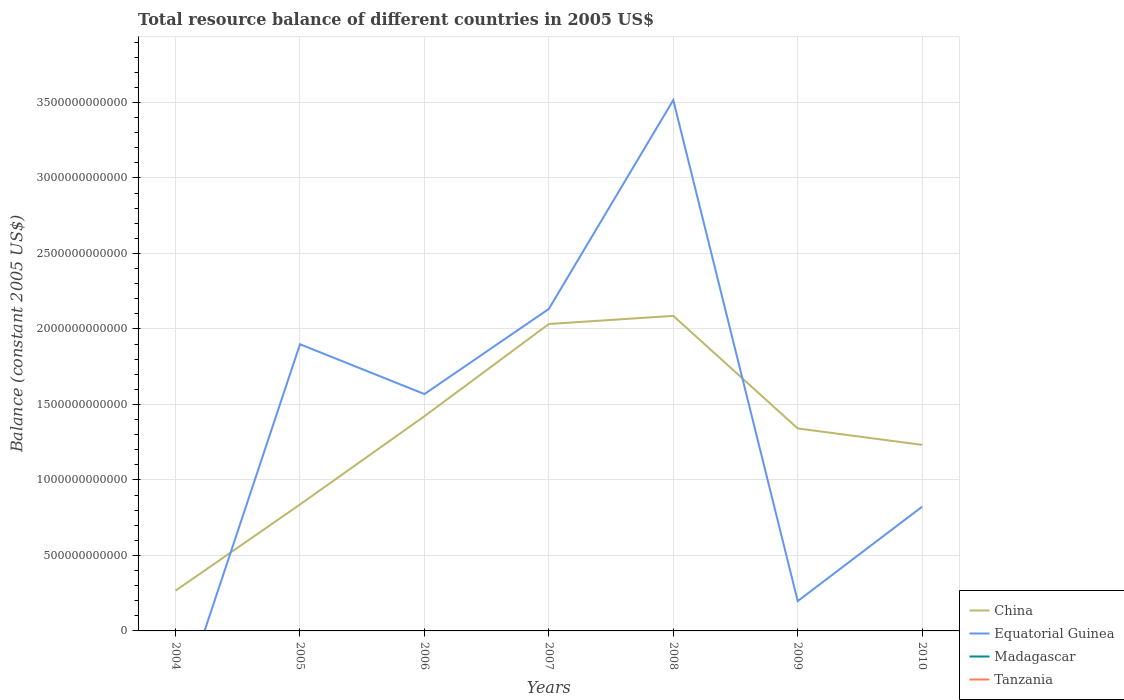How many different coloured lines are there?
Keep it short and to the point. 2. What is the total total resource balance in China in the graph?
Offer a very short reply. 1.09e+11. What is the difference between the highest and the second highest total resource balance in China?
Your response must be concise. 1.82e+12. Is the total resource balance in Equatorial Guinea strictly greater than the total resource balance in Madagascar over the years?
Provide a short and direct response. No. How many lines are there?
Ensure brevity in your answer.  2. What is the difference between two consecutive major ticks on the Y-axis?
Ensure brevity in your answer.  5.00e+11. Does the graph contain grids?
Your response must be concise. Yes. What is the title of the graph?
Your answer should be compact. Total resource balance of different countries in 2005 US$. Does "Cote d'Ivoire" appear as one of the legend labels in the graph?
Keep it short and to the point. No. What is the label or title of the X-axis?
Offer a terse response. Years. What is the label or title of the Y-axis?
Provide a short and direct response. Balance (constant 2005 US$). What is the Balance (constant 2005 US$) of China in 2004?
Ensure brevity in your answer.  2.67e+11. What is the Balance (constant 2005 US$) in China in 2005?
Offer a very short reply. 8.37e+11. What is the Balance (constant 2005 US$) of Equatorial Guinea in 2005?
Offer a very short reply. 1.90e+12. What is the Balance (constant 2005 US$) of Madagascar in 2005?
Your response must be concise. 0. What is the Balance (constant 2005 US$) in Tanzania in 2005?
Your answer should be very brief. 0. What is the Balance (constant 2005 US$) in China in 2006?
Make the answer very short. 1.42e+12. What is the Balance (constant 2005 US$) in Equatorial Guinea in 2006?
Make the answer very short. 1.57e+12. What is the Balance (constant 2005 US$) of Madagascar in 2006?
Provide a short and direct response. 0. What is the Balance (constant 2005 US$) of Tanzania in 2006?
Provide a succinct answer. 0. What is the Balance (constant 2005 US$) of China in 2007?
Provide a succinct answer. 2.03e+12. What is the Balance (constant 2005 US$) of Equatorial Guinea in 2007?
Your response must be concise. 2.13e+12. What is the Balance (constant 2005 US$) in China in 2008?
Offer a terse response. 2.09e+12. What is the Balance (constant 2005 US$) in Equatorial Guinea in 2008?
Offer a terse response. 3.52e+12. What is the Balance (constant 2005 US$) in Madagascar in 2008?
Ensure brevity in your answer.  0. What is the Balance (constant 2005 US$) in China in 2009?
Ensure brevity in your answer.  1.34e+12. What is the Balance (constant 2005 US$) in Equatorial Guinea in 2009?
Provide a succinct answer. 1.98e+11. What is the Balance (constant 2005 US$) in Tanzania in 2009?
Your answer should be compact. 0. What is the Balance (constant 2005 US$) of China in 2010?
Offer a very short reply. 1.23e+12. What is the Balance (constant 2005 US$) of Equatorial Guinea in 2010?
Give a very brief answer. 8.23e+11. Across all years, what is the maximum Balance (constant 2005 US$) of China?
Provide a succinct answer. 2.09e+12. Across all years, what is the maximum Balance (constant 2005 US$) in Equatorial Guinea?
Your response must be concise. 3.52e+12. Across all years, what is the minimum Balance (constant 2005 US$) of China?
Make the answer very short. 2.67e+11. Across all years, what is the minimum Balance (constant 2005 US$) of Equatorial Guinea?
Offer a very short reply. 0. What is the total Balance (constant 2005 US$) in China in the graph?
Your response must be concise. 9.22e+12. What is the total Balance (constant 2005 US$) of Equatorial Guinea in the graph?
Provide a short and direct response. 1.01e+13. What is the total Balance (constant 2005 US$) of Madagascar in the graph?
Your answer should be compact. 0. What is the difference between the Balance (constant 2005 US$) in China in 2004 and that in 2005?
Ensure brevity in your answer.  -5.71e+11. What is the difference between the Balance (constant 2005 US$) of China in 2004 and that in 2006?
Provide a short and direct response. -1.16e+12. What is the difference between the Balance (constant 2005 US$) in China in 2004 and that in 2007?
Offer a terse response. -1.77e+12. What is the difference between the Balance (constant 2005 US$) in China in 2004 and that in 2008?
Keep it short and to the point. -1.82e+12. What is the difference between the Balance (constant 2005 US$) of China in 2004 and that in 2009?
Offer a very short reply. -1.07e+12. What is the difference between the Balance (constant 2005 US$) in China in 2004 and that in 2010?
Offer a terse response. -9.66e+11. What is the difference between the Balance (constant 2005 US$) of China in 2005 and that in 2006?
Make the answer very short. -5.85e+11. What is the difference between the Balance (constant 2005 US$) of Equatorial Guinea in 2005 and that in 2006?
Offer a terse response. 3.30e+11. What is the difference between the Balance (constant 2005 US$) in China in 2005 and that in 2007?
Make the answer very short. -1.20e+12. What is the difference between the Balance (constant 2005 US$) in Equatorial Guinea in 2005 and that in 2007?
Your response must be concise. -2.34e+11. What is the difference between the Balance (constant 2005 US$) of China in 2005 and that in 2008?
Give a very brief answer. -1.25e+12. What is the difference between the Balance (constant 2005 US$) of Equatorial Guinea in 2005 and that in 2008?
Provide a short and direct response. -1.62e+12. What is the difference between the Balance (constant 2005 US$) in China in 2005 and that in 2009?
Offer a terse response. -5.04e+11. What is the difference between the Balance (constant 2005 US$) of Equatorial Guinea in 2005 and that in 2009?
Your answer should be compact. 1.70e+12. What is the difference between the Balance (constant 2005 US$) in China in 2005 and that in 2010?
Give a very brief answer. -3.95e+11. What is the difference between the Balance (constant 2005 US$) in Equatorial Guinea in 2005 and that in 2010?
Offer a terse response. 1.08e+12. What is the difference between the Balance (constant 2005 US$) in China in 2006 and that in 2007?
Give a very brief answer. -6.11e+11. What is the difference between the Balance (constant 2005 US$) in Equatorial Guinea in 2006 and that in 2007?
Keep it short and to the point. -5.64e+11. What is the difference between the Balance (constant 2005 US$) in China in 2006 and that in 2008?
Give a very brief answer. -6.65e+11. What is the difference between the Balance (constant 2005 US$) in Equatorial Guinea in 2006 and that in 2008?
Your answer should be compact. -1.95e+12. What is the difference between the Balance (constant 2005 US$) in China in 2006 and that in 2009?
Offer a terse response. 8.10e+1. What is the difference between the Balance (constant 2005 US$) in Equatorial Guinea in 2006 and that in 2009?
Provide a short and direct response. 1.37e+12. What is the difference between the Balance (constant 2005 US$) in China in 2006 and that in 2010?
Make the answer very short. 1.90e+11. What is the difference between the Balance (constant 2005 US$) in Equatorial Guinea in 2006 and that in 2010?
Provide a short and direct response. 7.46e+11. What is the difference between the Balance (constant 2005 US$) in China in 2007 and that in 2008?
Your response must be concise. -5.38e+1. What is the difference between the Balance (constant 2005 US$) in Equatorial Guinea in 2007 and that in 2008?
Offer a terse response. -1.38e+12. What is the difference between the Balance (constant 2005 US$) in China in 2007 and that in 2009?
Ensure brevity in your answer.  6.92e+11. What is the difference between the Balance (constant 2005 US$) of Equatorial Guinea in 2007 and that in 2009?
Your answer should be compact. 1.94e+12. What is the difference between the Balance (constant 2005 US$) in China in 2007 and that in 2010?
Make the answer very short. 8.01e+11. What is the difference between the Balance (constant 2005 US$) of Equatorial Guinea in 2007 and that in 2010?
Keep it short and to the point. 1.31e+12. What is the difference between the Balance (constant 2005 US$) of China in 2008 and that in 2009?
Ensure brevity in your answer.  7.46e+11. What is the difference between the Balance (constant 2005 US$) of Equatorial Guinea in 2008 and that in 2009?
Make the answer very short. 3.32e+12. What is the difference between the Balance (constant 2005 US$) of China in 2008 and that in 2010?
Keep it short and to the point. 8.54e+11. What is the difference between the Balance (constant 2005 US$) of Equatorial Guinea in 2008 and that in 2010?
Give a very brief answer. 2.69e+12. What is the difference between the Balance (constant 2005 US$) of China in 2009 and that in 2010?
Give a very brief answer. 1.09e+11. What is the difference between the Balance (constant 2005 US$) in Equatorial Guinea in 2009 and that in 2010?
Provide a succinct answer. -6.25e+11. What is the difference between the Balance (constant 2005 US$) in China in 2004 and the Balance (constant 2005 US$) in Equatorial Guinea in 2005?
Provide a short and direct response. -1.63e+12. What is the difference between the Balance (constant 2005 US$) of China in 2004 and the Balance (constant 2005 US$) of Equatorial Guinea in 2006?
Provide a short and direct response. -1.30e+12. What is the difference between the Balance (constant 2005 US$) of China in 2004 and the Balance (constant 2005 US$) of Equatorial Guinea in 2007?
Your answer should be very brief. -1.87e+12. What is the difference between the Balance (constant 2005 US$) in China in 2004 and the Balance (constant 2005 US$) in Equatorial Guinea in 2008?
Make the answer very short. -3.25e+12. What is the difference between the Balance (constant 2005 US$) of China in 2004 and the Balance (constant 2005 US$) of Equatorial Guinea in 2009?
Your response must be concise. 6.91e+1. What is the difference between the Balance (constant 2005 US$) of China in 2004 and the Balance (constant 2005 US$) of Equatorial Guinea in 2010?
Your answer should be compact. -5.56e+11. What is the difference between the Balance (constant 2005 US$) in China in 2005 and the Balance (constant 2005 US$) in Equatorial Guinea in 2006?
Offer a terse response. -7.31e+11. What is the difference between the Balance (constant 2005 US$) of China in 2005 and the Balance (constant 2005 US$) of Equatorial Guinea in 2007?
Your response must be concise. -1.30e+12. What is the difference between the Balance (constant 2005 US$) in China in 2005 and the Balance (constant 2005 US$) in Equatorial Guinea in 2008?
Your response must be concise. -2.68e+12. What is the difference between the Balance (constant 2005 US$) in China in 2005 and the Balance (constant 2005 US$) in Equatorial Guinea in 2009?
Give a very brief answer. 6.40e+11. What is the difference between the Balance (constant 2005 US$) of China in 2005 and the Balance (constant 2005 US$) of Equatorial Guinea in 2010?
Make the answer very short. 1.44e+1. What is the difference between the Balance (constant 2005 US$) in China in 2006 and the Balance (constant 2005 US$) in Equatorial Guinea in 2007?
Offer a very short reply. -7.11e+11. What is the difference between the Balance (constant 2005 US$) in China in 2006 and the Balance (constant 2005 US$) in Equatorial Guinea in 2008?
Offer a terse response. -2.09e+12. What is the difference between the Balance (constant 2005 US$) in China in 2006 and the Balance (constant 2005 US$) in Equatorial Guinea in 2009?
Keep it short and to the point. 1.22e+12. What is the difference between the Balance (constant 2005 US$) in China in 2006 and the Balance (constant 2005 US$) in Equatorial Guinea in 2010?
Your answer should be very brief. 5.99e+11. What is the difference between the Balance (constant 2005 US$) in China in 2007 and the Balance (constant 2005 US$) in Equatorial Guinea in 2008?
Offer a terse response. -1.48e+12. What is the difference between the Balance (constant 2005 US$) of China in 2007 and the Balance (constant 2005 US$) of Equatorial Guinea in 2009?
Your response must be concise. 1.84e+12. What is the difference between the Balance (constant 2005 US$) in China in 2007 and the Balance (constant 2005 US$) in Equatorial Guinea in 2010?
Your answer should be very brief. 1.21e+12. What is the difference between the Balance (constant 2005 US$) in China in 2008 and the Balance (constant 2005 US$) in Equatorial Guinea in 2009?
Your response must be concise. 1.89e+12. What is the difference between the Balance (constant 2005 US$) in China in 2008 and the Balance (constant 2005 US$) in Equatorial Guinea in 2010?
Provide a succinct answer. 1.26e+12. What is the difference between the Balance (constant 2005 US$) in China in 2009 and the Balance (constant 2005 US$) in Equatorial Guinea in 2010?
Offer a terse response. 5.18e+11. What is the average Balance (constant 2005 US$) of China per year?
Provide a short and direct response. 1.32e+12. What is the average Balance (constant 2005 US$) of Equatorial Guinea per year?
Provide a short and direct response. 1.45e+12. What is the average Balance (constant 2005 US$) in Madagascar per year?
Provide a succinct answer. 0. In the year 2005, what is the difference between the Balance (constant 2005 US$) of China and Balance (constant 2005 US$) of Equatorial Guinea?
Provide a succinct answer. -1.06e+12. In the year 2006, what is the difference between the Balance (constant 2005 US$) in China and Balance (constant 2005 US$) in Equatorial Guinea?
Your answer should be very brief. -1.47e+11. In the year 2007, what is the difference between the Balance (constant 2005 US$) in China and Balance (constant 2005 US$) in Equatorial Guinea?
Your response must be concise. -9.99e+1. In the year 2008, what is the difference between the Balance (constant 2005 US$) in China and Balance (constant 2005 US$) in Equatorial Guinea?
Make the answer very short. -1.43e+12. In the year 2009, what is the difference between the Balance (constant 2005 US$) in China and Balance (constant 2005 US$) in Equatorial Guinea?
Ensure brevity in your answer.  1.14e+12. In the year 2010, what is the difference between the Balance (constant 2005 US$) in China and Balance (constant 2005 US$) in Equatorial Guinea?
Provide a short and direct response. 4.09e+11. What is the ratio of the Balance (constant 2005 US$) of China in 2004 to that in 2005?
Offer a terse response. 0.32. What is the ratio of the Balance (constant 2005 US$) in China in 2004 to that in 2006?
Your answer should be compact. 0.19. What is the ratio of the Balance (constant 2005 US$) in China in 2004 to that in 2007?
Keep it short and to the point. 0.13. What is the ratio of the Balance (constant 2005 US$) in China in 2004 to that in 2008?
Keep it short and to the point. 0.13. What is the ratio of the Balance (constant 2005 US$) in China in 2004 to that in 2009?
Your answer should be very brief. 0.2. What is the ratio of the Balance (constant 2005 US$) of China in 2004 to that in 2010?
Your response must be concise. 0.22. What is the ratio of the Balance (constant 2005 US$) of China in 2005 to that in 2006?
Provide a short and direct response. 0.59. What is the ratio of the Balance (constant 2005 US$) of Equatorial Guinea in 2005 to that in 2006?
Provide a succinct answer. 1.21. What is the ratio of the Balance (constant 2005 US$) of China in 2005 to that in 2007?
Offer a very short reply. 0.41. What is the ratio of the Balance (constant 2005 US$) in Equatorial Guinea in 2005 to that in 2007?
Your answer should be compact. 0.89. What is the ratio of the Balance (constant 2005 US$) in China in 2005 to that in 2008?
Your answer should be compact. 0.4. What is the ratio of the Balance (constant 2005 US$) in Equatorial Guinea in 2005 to that in 2008?
Your response must be concise. 0.54. What is the ratio of the Balance (constant 2005 US$) of China in 2005 to that in 2009?
Provide a short and direct response. 0.62. What is the ratio of the Balance (constant 2005 US$) in Equatorial Guinea in 2005 to that in 2009?
Your answer should be compact. 9.61. What is the ratio of the Balance (constant 2005 US$) in China in 2005 to that in 2010?
Offer a terse response. 0.68. What is the ratio of the Balance (constant 2005 US$) in Equatorial Guinea in 2005 to that in 2010?
Give a very brief answer. 2.31. What is the ratio of the Balance (constant 2005 US$) in China in 2006 to that in 2007?
Keep it short and to the point. 0.7. What is the ratio of the Balance (constant 2005 US$) of Equatorial Guinea in 2006 to that in 2007?
Offer a terse response. 0.74. What is the ratio of the Balance (constant 2005 US$) of China in 2006 to that in 2008?
Provide a succinct answer. 0.68. What is the ratio of the Balance (constant 2005 US$) in Equatorial Guinea in 2006 to that in 2008?
Your response must be concise. 0.45. What is the ratio of the Balance (constant 2005 US$) of China in 2006 to that in 2009?
Offer a very short reply. 1.06. What is the ratio of the Balance (constant 2005 US$) of Equatorial Guinea in 2006 to that in 2009?
Your response must be concise. 7.94. What is the ratio of the Balance (constant 2005 US$) in China in 2006 to that in 2010?
Give a very brief answer. 1.15. What is the ratio of the Balance (constant 2005 US$) of Equatorial Guinea in 2006 to that in 2010?
Keep it short and to the point. 1.91. What is the ratio of the Balance (constant 2005 US$) of China in 2007 to that in 2008?
Provide a succinct answer. 0.97. What is the ratio of the Balance (constant 2005 US$) of Equatorial Guinea in 2007 to that in 2008?
Ensure brevity in your answer.  0.61. What is the ratio of the Balance (constant 2005 US$) of China in 2007 to that in 2009?
Ensure brevity in your answer.  1.52. What is the ratio of the Balance (constant 2005 US$) of Equatorial Guinea in 2007 to that in 2009?
Give a very brief answer. 10.79. What is the ratio of the Balance (constant 2005 US$) in China in 2007 to that in 2010?
Keep it short and to the point. 1.65. What is the ratio of the Balance (constant 2005 US$) of Equatorial Guinea in 2007 to that in 2010?
Offer a very short reply. 2.59. What is the ratio of the Balance (constant 2005 US$) in China in 2008 to that in 2009?
Your answer should be compact. 1.56. What is the ratio of the Balance (constant 2005 US$) of Equatorial Guinea in 2008 to that in 2009?
Give a very brief answer. 17.79. What is the ratio of the Balance (constant 2005 US$) of China in 2008 to that in 2010?
Your response must be concise. 1.69. What is the ratio of the Balance (constant 2005 US$) in Equatorial Guinea in 2008 to that in 2010?
Offer a very short reply. 4.27. What is the ratio of the Balance (constant 2005 US$) of China in 2009 to that in 2010?
Ensure brevity in your answer.  1.09. What is the ratio of the Balance (constant 2005 US$) in Equatorial Guinea in 2009 to that in 2010?
Provide a short and direct response. 0.24. What is the difference between the highest and the second highest Balance (constant 2005 US$) in China?
Ensure brevity in your answer.  5.38e+1. What is the difference between the highest and the second highest Balance (constant 2005 US$) in Equatorial Guinea?
Offer a terse response. 1.38e+12. What is the difference between the highest and the lowest Balance (constant 2005 US$) in China?
Give a very brief answer. 1.82e+12. What is the difference between the highest and the lowest Balance (constant 2005 US$) of Equatorial Guinea?
Ensure brevity in your answer.  3.52e+12. 